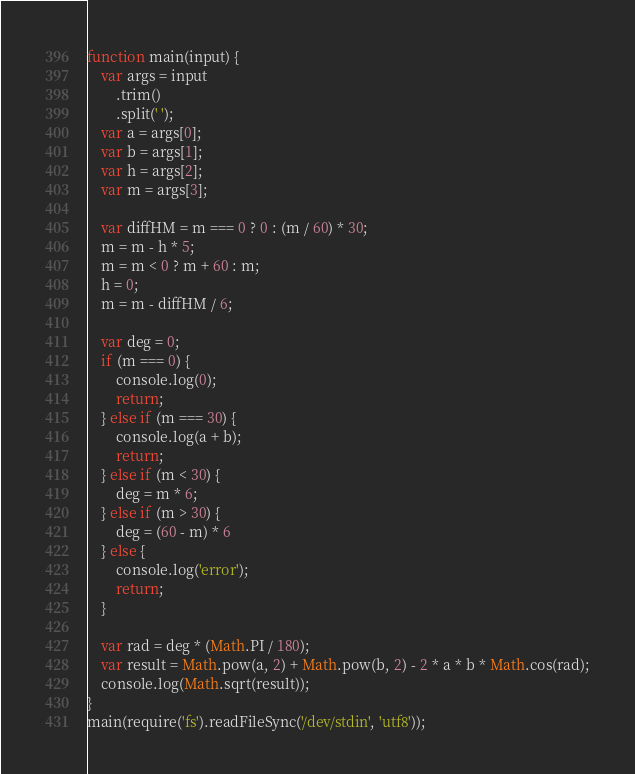Convert code to text. <code><loc_0><loc_0><loc_500><loc_500><_JavaScript_>function main(input) {
    var args = input
        .trim()
        .split(' ');
    var a = args[0];
    var b = args[1];
    var h = args[2];
    var m = args[3];

    var diffHM = m === 0 ? 0 : (m / 60) * 30;
    m = m - h * 5;
    m = m < 0 ? m + 60 : m;
    h = 0;
    m = m - diffHM / 6;

    var deg = 0;
    if (m === 0) {
        console.log(0);
        return;
    } else if (m === 30) {
        console.log(a + b);
        return;
    } else if (m < 30) {
        deg = m * 6;
    } else if (m > 30) {
        deg = (60 - m) * 6
    } else {
        console.log('error');
        return;
    }

    var rad = deg * (Math.PI / 180);
    var result = Math.pow(a, 2) + Math.pow(b, 2) - 2 * a * b * Math.cos(rad);
    console.log(Math.sqrt(result));
}
main(require('fs').readFileSync('/dev/stdin', 'utf8'));
</code> 